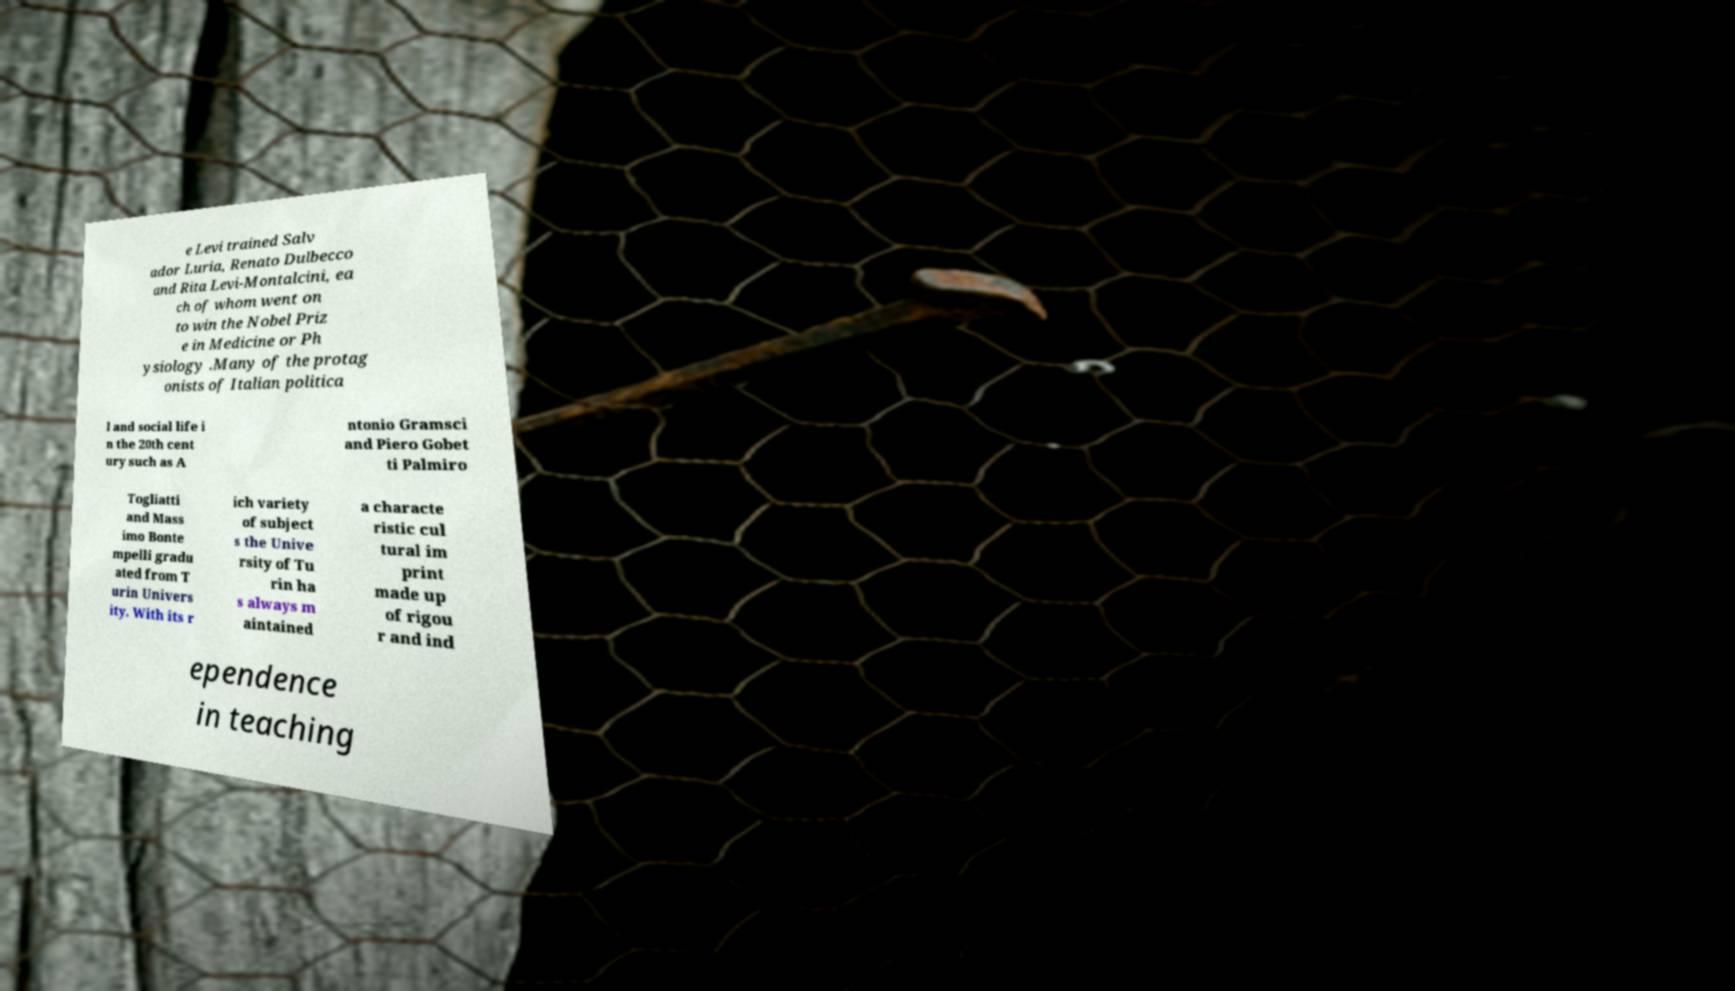There's text embedded in this image that I need extracted. Can you transcribe it verbatim? e Levi trained Salv ador Luria, Renato Dulbecco and Rita Levi-Montalcini, ea ch of whom went on to win the Nobel Priz e in Medicine or Ph ysiology .Many of the protag onists of Italian politica l and social life i n the 20th cent ury such as A ntonio Gramsci and Piero Gobet ti Palmiro Togliatti and Mass imo Bonte mpelli gradu ated from T urin Univers ity. With its r ich variety of subject s the Unive rsity of Tu rin ha s always m aintained a characte ristic cul tural im print made up of rigou r and ind ependence in teaching 